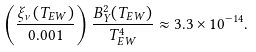<formula> <loc_0><loc_0><loc_500><loc_500>\left ( \frac { \xi _ { \nu } ( T _ { E W } ) } { 0 . 0 0 1 } \right ) \frac { B _ { Y } ^ { 2 } ( T _ { E W } ) } { T _ { E W } ^ { 4 } } \approx 3 . 3 \times 1 0 ^ { - 1 4 } .</formula> 